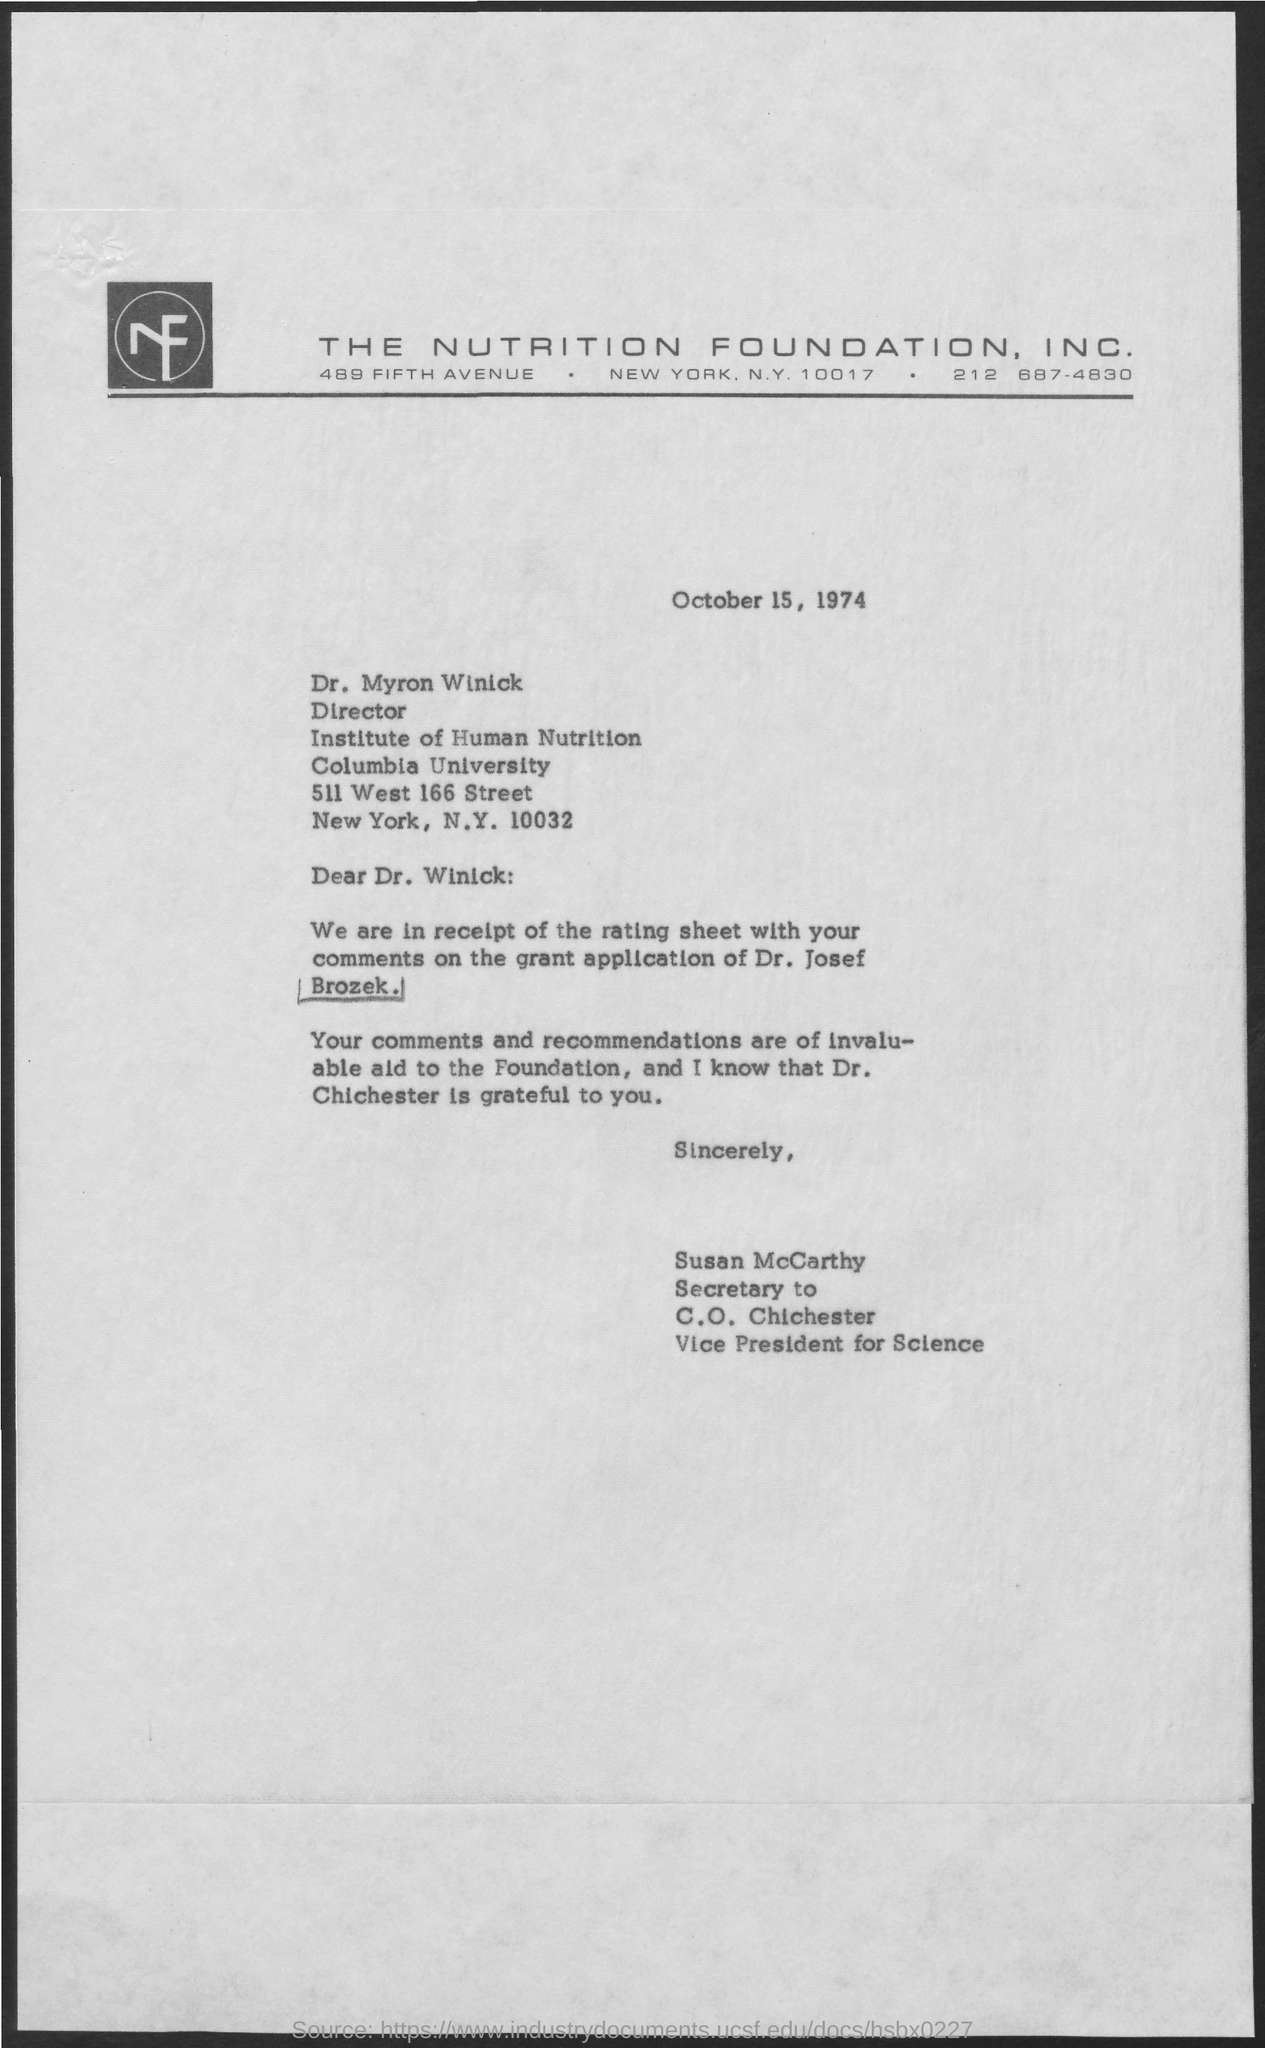To Whom is this letter addressed to?
Offer a very short reply. Dr. Myron Winick. Who is grateful for the recommendations?
Ensure brevity in your answer.  Dr. Chichester. 